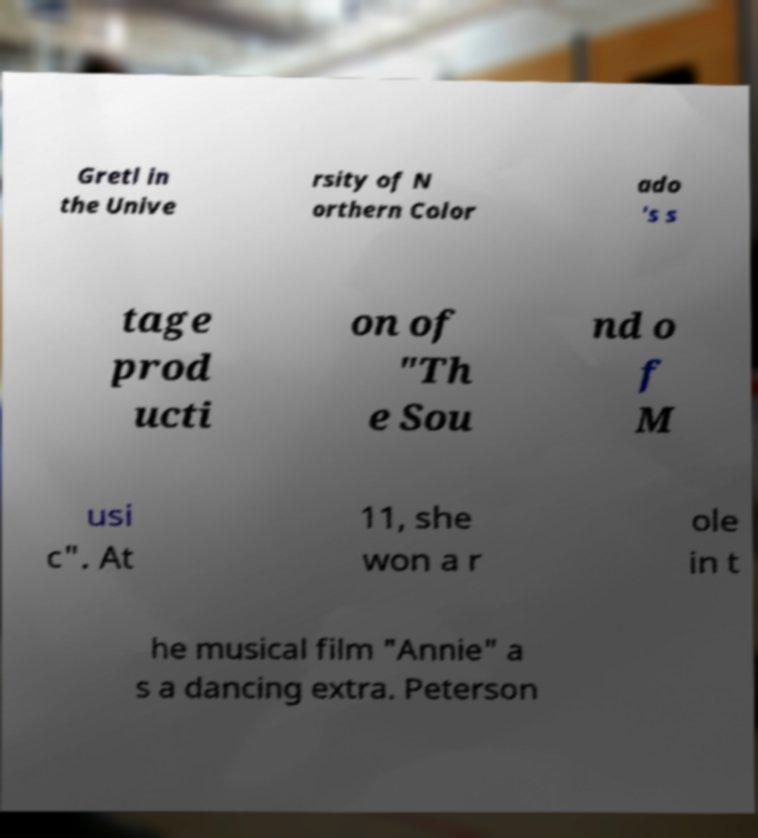Please read and relay the text visible in this image. What does it say? Gretl in the Unive rsity of N orthern Color ado 's s tage prod ucti on of "Th e Sou nd o f M usi c". At 11, she won a r ole in t he musical film "Annie" a s a dancing extra. Peterson 